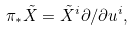Convert formula to latex. <formula><loc_0><loc_0><loc_500><loc_500>\pi _ { * } \tilde { X } = \tilde { X } ^ { i } \partial / \partial u ^ { i } ,</formula> 